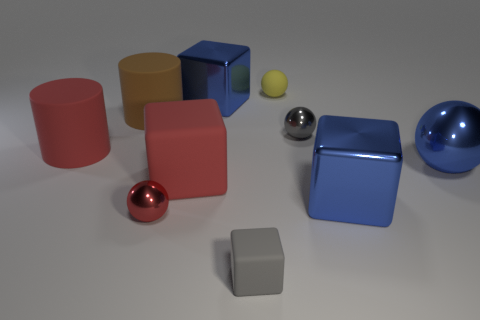Subtract all small gray spheres. How many spheres are left? 3 Subtract all blue balls. How many balls are left? 3 Subtract 1 cylinders. How many cylinders are left? 1 Subtract all cylinders. How many objects are left? 8 Subtract all blue cylinders. Subtract all red cubes. How many cylinders are left? 2 Subtract all cyan cubes. How many red cylinders are left? 1 Subtract all big red rubber cylinders. Subtract all large brown rubber cylinders. How many objects are left? 8 Add 4 big brown cylinders. How many big brown cylinders are left? 5 Add 4 tiny yellow matte spheres. How many tiny yellow matte spheres exist? 5 Subtract 1 brown cylinders. How many objects are left? 9 